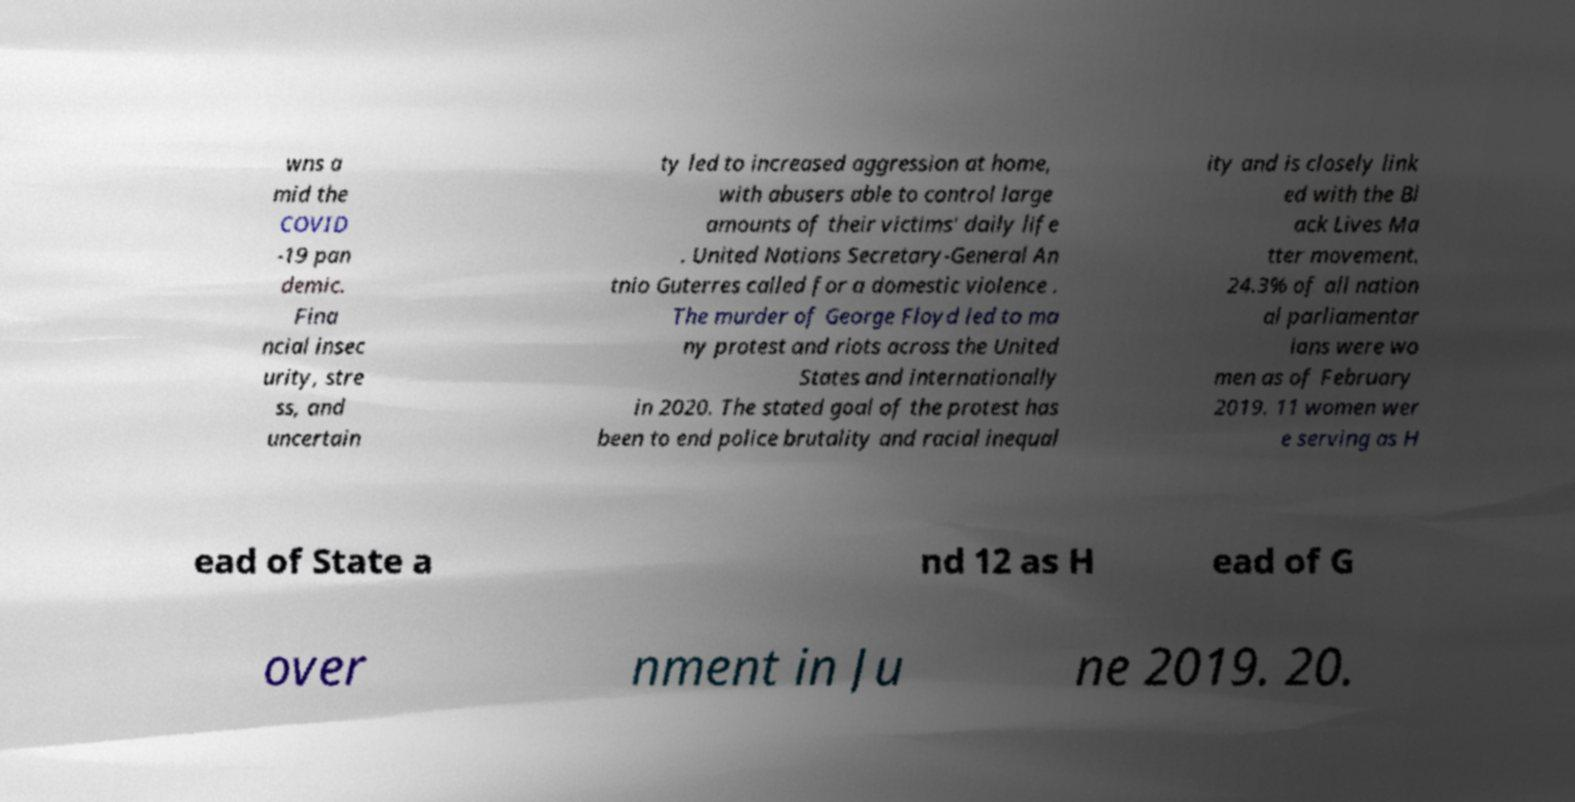What messages or text are displayed in this image? I need them in a readable, typed format. wns a mid the COVID -19 pan demic. Fina ncial insec urity, stre ss, and uncertain ty led to increased aggression at home, with abusers able to control large amounts of their victims' daily life . United Nations Secretary-General An tnio Guterres called for a domestic violence . The murder of George Floyd led to ma ny protest and riots across the United States and internationally in 2020. The stated goal of the protest has been to end police brutality and racial inequal ity and is closely link ed with the Bl ack Lives Ma tter movement. 24.3% of all nation al parliamentar ians were wo men as of February 2019. 11 women wer e serving as H ead of State a nd 12 as H ead of G over nment in Ju ne 2019. 20. 